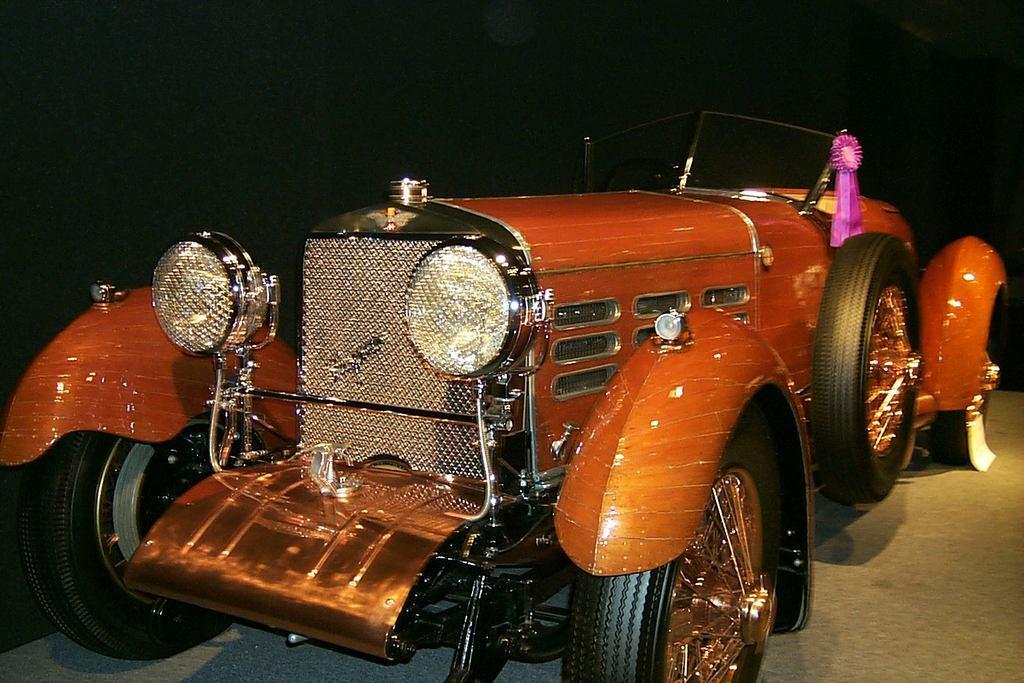In one or two sentences, can you explain what this image depicts? In the center of the image we can see a vehicle. At the bottom there is a road. 